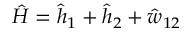Convert formula to latex. <formula><loc_0><loc_0><loc_500><loc_500>\hat { H } = \hat { h } _ { 1 } + \hat { h } _ { 2 } + \hat { w } _ { 1 2 }</formula> 